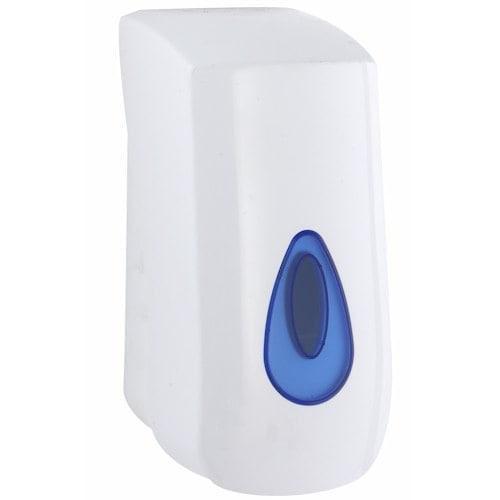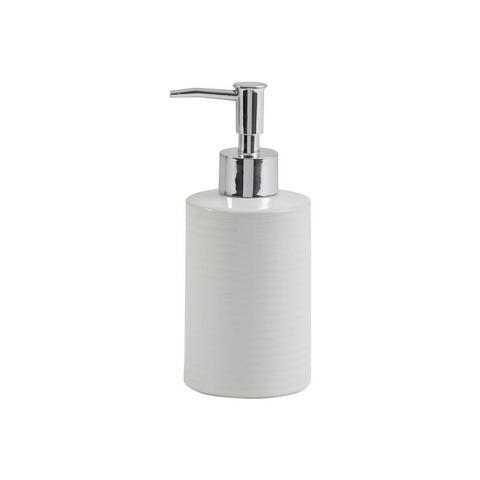The first image is the image on the left, the second image is the image on the right. Evaluate the accuracy of this statement regarding the images: "One image is a standard dispenser with a pump top that does not show the level of the contents.". Is it true? Answer yes or no. Yes. 